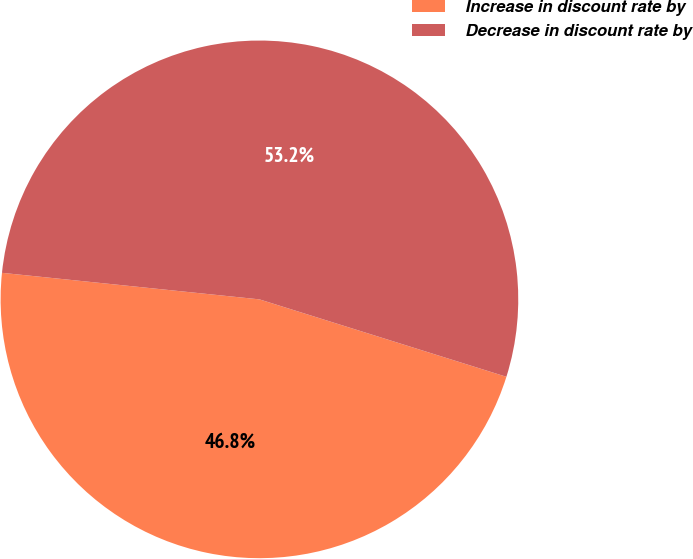<chart> <loc_0><loc_0><loc_500><loc_500><pie_chart><fcel>Increase in discount rate by<fcel>Decrease in discount rate by<nl><fcel>46.8%<fcel>53.2%<nl></chart> 